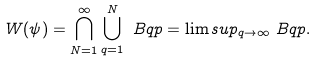<formula> <loc_0><loc_0><loc_500><loc_500>W ( \psi ) & = \bigcap _ { N = 1 } ^ { \infty } \bigcup _ { q = 1 } ^ { N } \ B q p = \lim s u p _ { q \to \infty } \ B q p .</formula> 